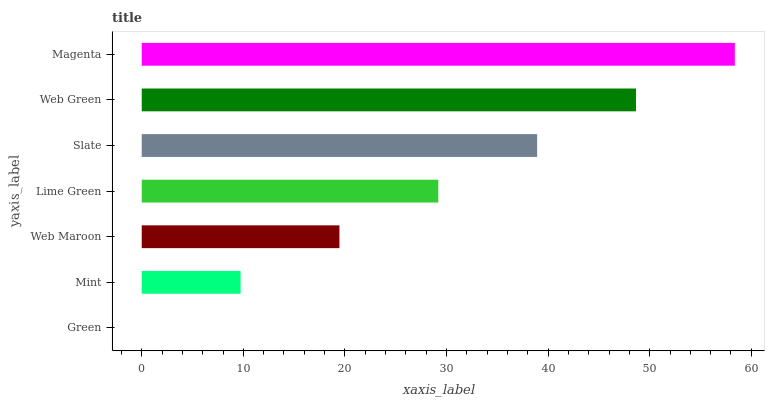Is Green the minimum?
Answer yes or no. Yes. Is Magenta the maximum?
Answer yes or no. Yes. Is Mint the minimum?
Answer yes or no. No. Is Mint the maximum?
Answer yes or no. No. Is Mint greater than Green?
Answer yes or no. Yes. Is Green less than Mint?
Answer yes or no. Yes. Is Green greater than Mint?
Answer yes or no. No. Is Mint less than Green?
Answer yes or no. No. Is Lime Green the high median?
Answer yes or no. Yes. Is Lime Green the low median?
Answer yes or no. Yes. Is Magenta the high median?
Answer yes or no. No. Is Mint the low median?
Answer yes or no. No. 